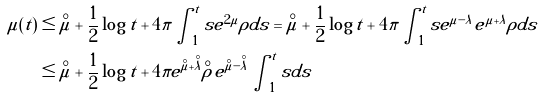<formula> <loc_0><loc_0><loc_500><loc_500>\mu ( t ) & \leq \overset { \circ } { \mu } + \frac { 1 } { 2 } \log t + 4 \pi \int _ { 1 } ^ { t } s e ^ { 2 \mu } \rho d s = \overset { \circ } { \mu } + \frac { 1 } { 2 } \log t + 4 \pi \int _ { 1 } ^ { t } s e ^ { \mu - \lambda } e ^ { \mu + \lambda } \rho d s \\ & \leq \overset { \circ } { \mu } + \frac { 1 } { 2 } \log t + 4 \pi e ^ { \overset { \circ } { \mu } + \overset { \circ } { \lambda } } \overset { \circ } { \rho } e ^ { \overset { \circ } { \mu } - \overset { \circ } { \lambda } } \int _ { 1 } ^ { t } s d s</formula> 